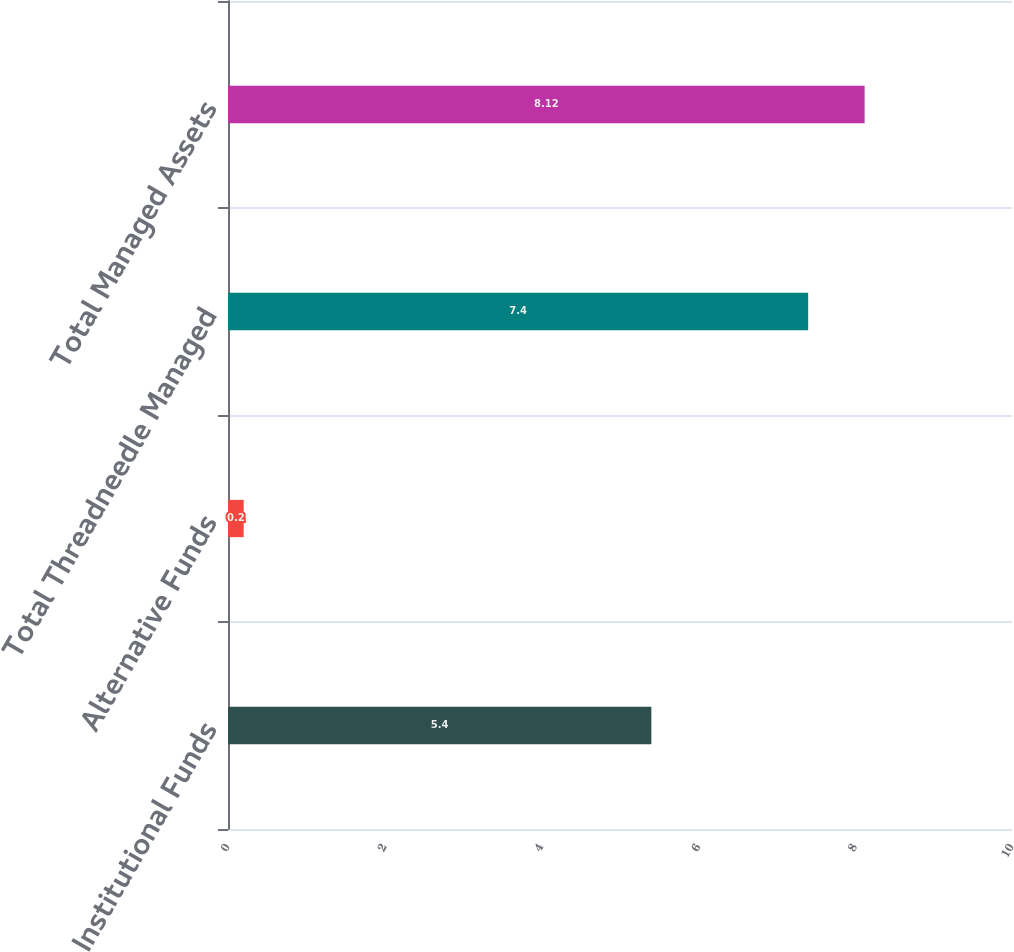Convert chart to OTSL. <chart><loc_0><loc_0><loc_500><loc_500><bar_chart><fcel>Institutional Funds<fcel>Alternative Funds<fcel>Total Threadneedle Managed<fcel>Total Managed Assets<nl><fcel>5.4<fcel>0.2<fcel>7.4<fcel>8.12<nl></chart> 